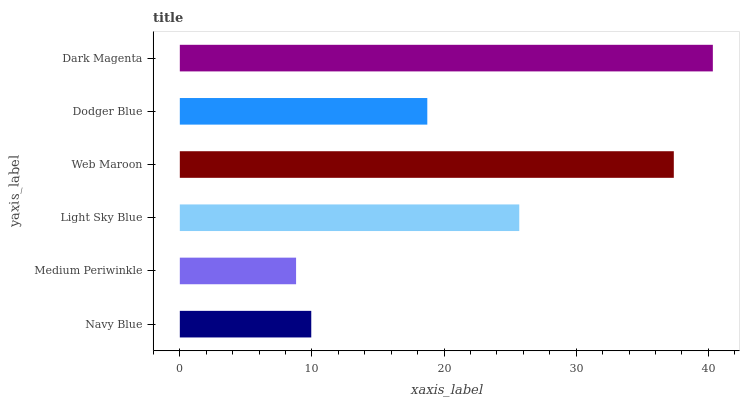Is Medium Periwinkle the minimum?
Answer yes or no. Yes. Is Dark Magenta the maximum?
Answer yes or no. Yes. Is Light Sky Blue the minimum?
Answer yes or no. No. Is Light Sky Blue the maximum?
Answer yes or no. No. Is Light Sky Blue greater than Medium Periwinkle?
Answer yes or no. Yes. Is Medium Periwinkle less than Light Sky Blue?
Answer yes or no. Yes. Is Medium Periwinkle greater than Light Sky Blue?
Answer yes or no. No. Is Light Sky Blue less than Medium Periwinkle?
Answer yes or no. No. Is Light Sky Blue the high median?
Answer yes or no. Yes. Is Dodger Blue the low median?
Answer yes or no. Yes. Is Medium Periwinkle the high median?
Answer yes or no. No. Is Medium Periwinkle the low median?
Answer yes or no. No. 